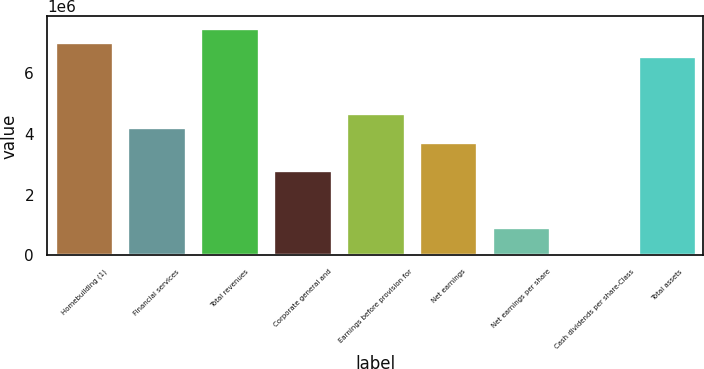Convert chart. <chart><loc_0><loc_0><loc_500><loc_500><bar_chart><fcel>Homebuilding (1)<fcel>Financial services<fcel>Total revenues<fcel>Corporate general and<fcel>Earnings before provision for<fcel>Net earnings<fcel>Net earnings per share<fcel>Cash dividends per share-Class<fcel>Total assets<nl><fcel>7.01845e+06<fcel>4.21107e+06<fcel>7.48635e+06<fcel>2.80738e+06<fcel>4.67897e+06<fcel>3.74317e+06<fcel>935794<fcel>0.02<fcel>6.55056e+06<nl></chart> 